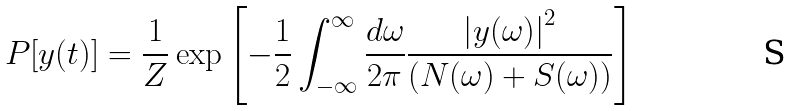Convert formula to latex. <formula><loc_0><loc_0><loc_500><loc_500>P [ y ( t ) ] = \frac { 1 } { Z } \exp \left [ - \frac { 1 } { 2 } \int _ { - \infty } ^ { \infty } \frac { d \omega } { 2 \pi } \frac { \left | y ( \omega ) \right | ^ { 2 } } { \left ( N ( \omega ) + S ( \omega ) \right ) } \right ]</formula> 